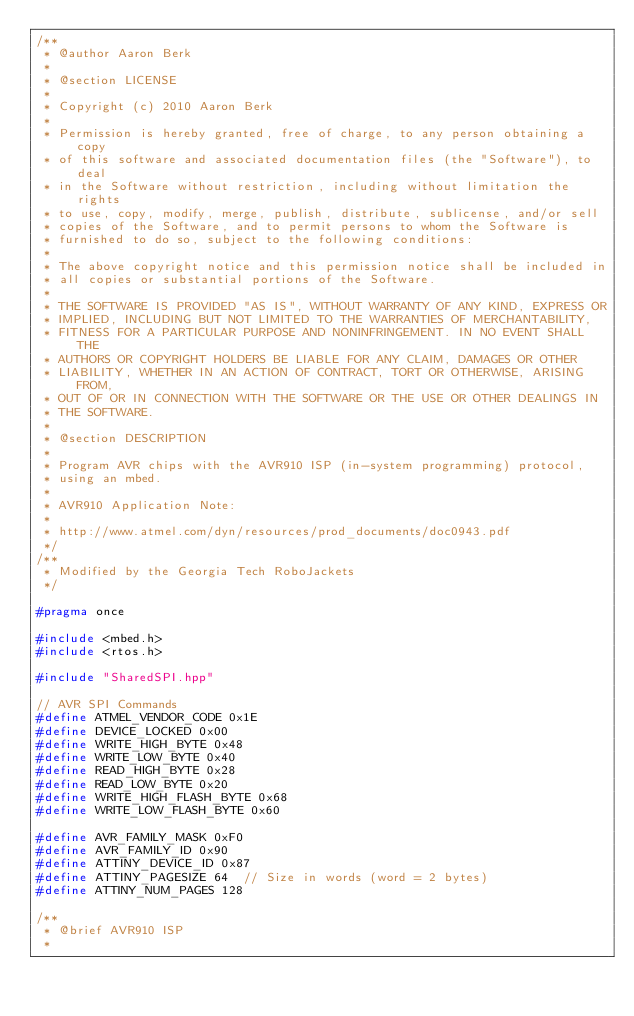Convert code to text. <code><loc_0><loc_0><loc_500><loc_500><_C++_>/**
 * @author Aaron Berk
 *
 * @section LICENSE
 *
 * Copyright (c) 2010 Aaron Berk
 *
 * Permission is hereby granted, free of charge, to any person obtaining a copy
 * of this software and associated documentation files (the "Software"), to deal
 * in the Software without restriction, including without limitation the rights
 * to use, copy, modify, merge, publish, distribute, sublicense, and/or sell
 * copies of the Software, and to permit persons to whom the Software is
 * furnished to do so, subject to the following conditions:
 *
 * The above copyright notice and this permission notice shall be included in
 * all copies or substantial portions of the Software.
 *
 * THE SOFTWARE IS PROVIDED "AS IS", WITHOUT WARRANTY OF ANY KIND, EXPRESS OR
 * IMPLIED, INCLUDING BUT NOT LIMITED TO THE WARRANTIES OF MERCHANTABILITY,
 * FITNESS FOR A PARTICULAR PURPOSE AND NONINFRINGEMENT. IN NO EVENT SHALL THE
 * AUTHORS OR COPYRIGHT HOLDERS BE LIABLE FOR ANY CLAIM, DAMAGES OR OTHER
 * LIABILITY, WHETHER IN AN ACTION OF CONTRACT, TORT OR OTHERWISE, ARISING FROM,
 * OUT OF OR IN CONNECTION WITH THE SOFTWARE OR THE USE OR OTHER DEALINGS IN
 * THE SOFTWARE.
 *
 * @section DESCRIPTION
 *
 * Program AVR chips with the AVR910 ISP (in-system programming) protocol,
 * using an mbed.
 *
 * AVR910 Application Note:
 *
 * http://www.atmel.com/dyn/resources/prod_documents/doc0943.pdf
 */
/**
 * Modified by the Georgia Tech RoboJackets
 */

#pragma once

#include <mbed.h>
#include <rtos.h>

#include "SharedSPI.hpp"

// AVR SPI Commands
#define ATMEL_VENDOR_CODE 0x1E
#define DEVICE_LOCKED 0x00
#define WRITE_HIGH_BYTE 0x48
#define WRITE_LOW_BYTE 0x40
#define READ_HIGH_BYTE 0x28
#define READ_LOW_BYTE 0x20
#define WRITE_HIGH_FLASH_BYTE 0x68
#define WRITE_LOW_FLASH_BYTE 0x60

#define AVR_FAMILY_MASK 0xF0
#define AVR_FAMILY_ID 0x90
#define ATTINY_DEVICE_ID 0x87
#define ATTINY_PAGESIZE 64  // Size in words (word = 2 bytes)
#define ATTINY_NUM_PAGES 128

/**
 * @brief AVR910 ISP
 *</code> 